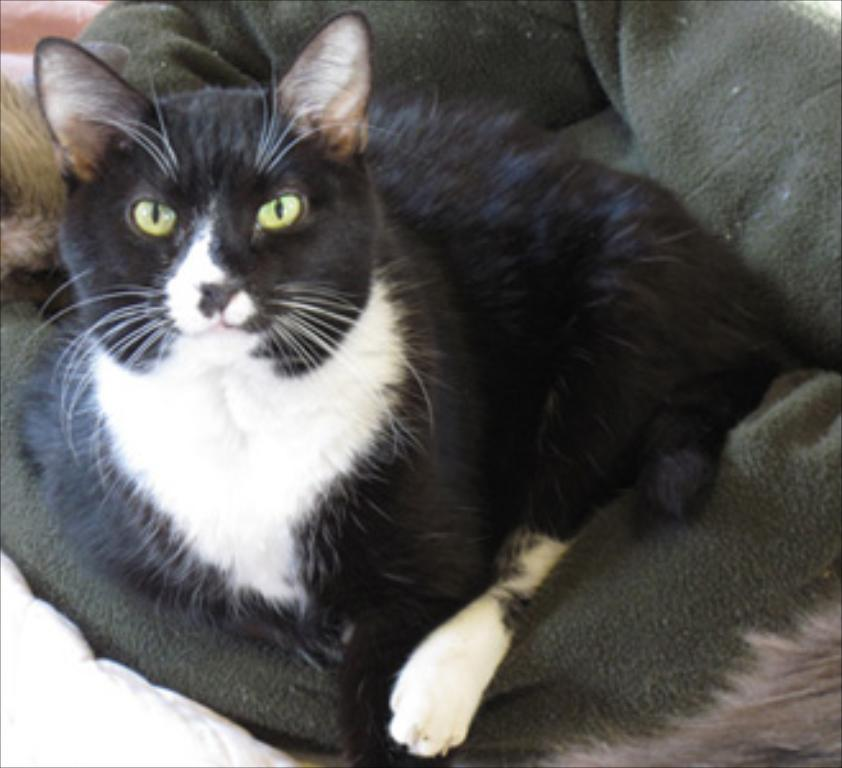What type of animal is in the image? There is a cat in the image. Can you describe the color of the cat? The cat is black and white in color. Where is the cat located in the image? The cat is sitting on a cat bed. What type of magic does the cat perform in the image? There is no magic or any magical activity performed by the cat in the image. 